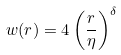<formula> <loc_0><loc_0><loc_500><loc_500>w ( r ) = 4 \left ( \frac { r } { \eta } \right ) ^ { \delta }</formula> 